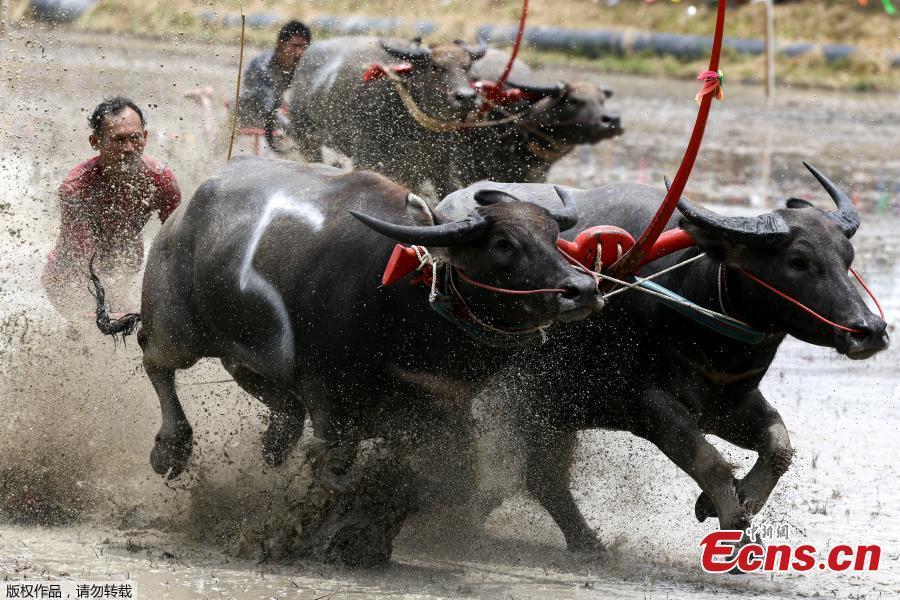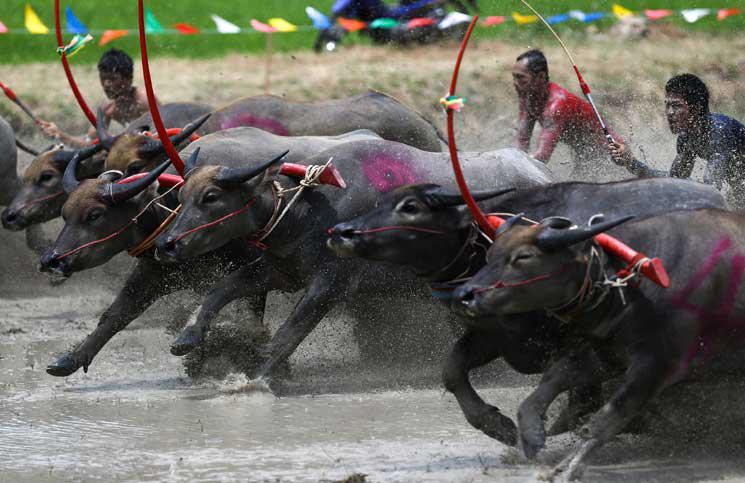The first image is the image on the left, the second image is the image on the right. Assess this claim about the two images: "Every single bovine appears to be part of a race.". Correct or not? Answer yes or no. Yes. 